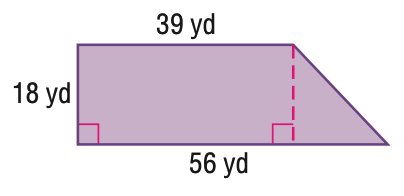Answer the mathemtical geometry problem and directly provide the correct option letter.
Question: Find the area of the figure. Round to the nearest tenth if necessary.
Choices: A: 702 B: 855 C: 1008 D: 1710 B 